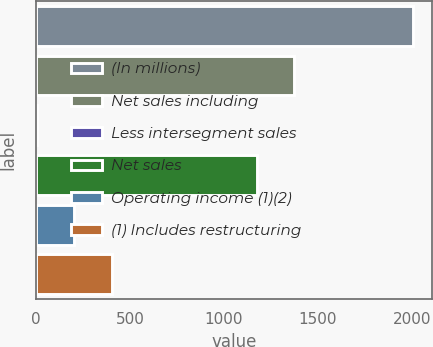Convert chart to OTSL. <chart><loc_0><loc_0><loc_500><loc_500><bar_chart><fcel>(In millions)<fcel>Net sales including<fcel>Less intersegment sales<fcel>Net sales<fcel>Operating income (1)(2)<fcel>(1) Includes restructuring<nl><fcel>2007<fcel>1374.99<fcel>2.1<fcel>1174.5<fcel>202.59<fcel>403.08<nl></chart> 